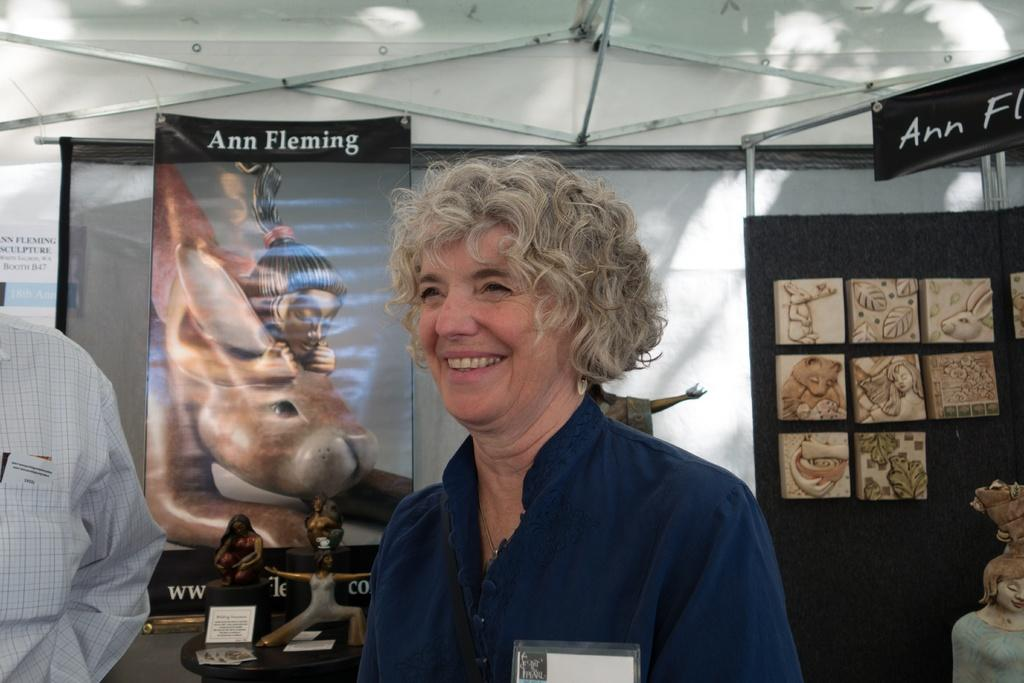Who is the main subject in the foreground of the image? There is a lady and a person in the foreground of the image. What can be seen in the background of the image? There are posters, trophies, and a wall in the background of the image. What type of letters are being used to spell out the word "spade" on the jar in the image? There is no jar or word "spade" present in the image. 